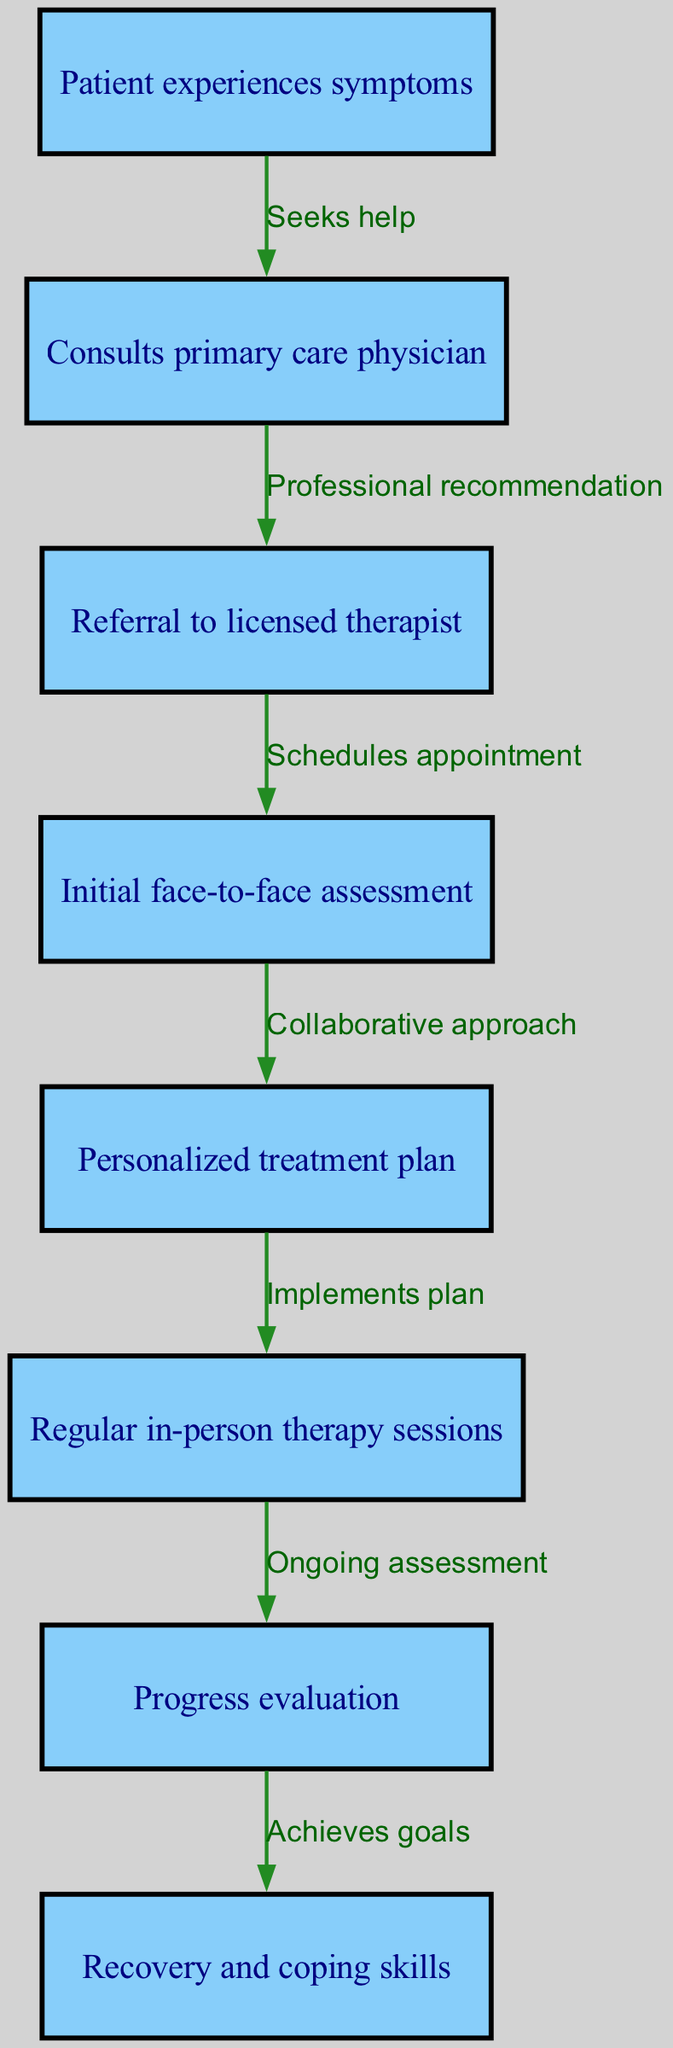What is the first step a patient takes in the journey? The diagram starts with the node that indicates the first action the patient takes, which is experiencing symptoms. This is the starting point of the flowchart.
Answer: Patient experiences symptoms How many nodes are in the diagram? By counting all the distinct nodes listed in the flowchart, we can determine the total number. There are eight unique steps representing the patient's journey.
Answer: Eight What is the action taken after consulting the primary care physician? The flowchart indicates that following a consultation with a primary care physician, the next step is a referral to a licensed therapist. This relationship is directly shown with an edge leading from the second node to the third.
Answer: Referral to licensed therapist What follows the initial face-to-face assessment? In the flowchart sequence, after the initial face-to-face assessment, the next step involves developing a personalized treatment plan. This progression is represented with an edge connecting the fourth node to the fifth node.
Answer: Personalized treatment plan What is included in the progress evaluation? The progress evaluation node indicates an ongoing assessment of the patient's journey through therapy. This involves evaluating the patient's status, which is the core purpose of the node.
Answer: Ongoing assessment What relationship exists between the treatment plan and therapy sessions? The flowchart illustrates that the implementation of the personalized treatment plan directly leads to the regular in-person therapy sessions. The connection is established through an edge that links the fifth node to the sixth node, indicating a direct action.
Answer: Implements plan How many edges are in the diagram? By examining the flow connections between the nodes, we can ascertain the total lines representing transitions. There are seven edges that delineate the various steps in the patient journey.
Answer: Seven What is the last step in the patient’s journey toward recovery? The final step of the journey is depicted in the last node, which indicates that the patient achieves recovery and coping skills. This conclusion is reached after all previous steps have been followed.
Answer: Recovery and coping skills What action is taken before progressing to the recovery step? The diagram shows that before reaching the recovery and coping skills stage, patients undergo a progress evaluation. This step is essential for confirming they're on the right path and can continue to the final outcome.
Answer: Achieves goals 